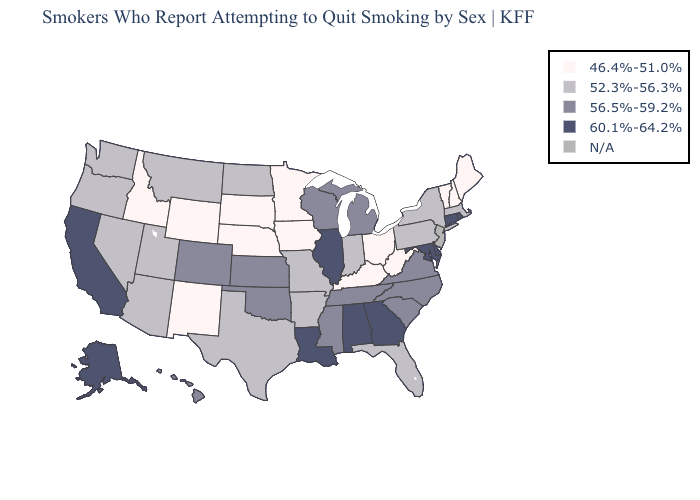Does Georgia have the lowest value in the USA?
Keep it brief. No. Does Washington have the highest value in the West?
Concise answer only. No. What is the lowest value in the South?
Quick response, please. 46.4%-51.0%. Name the states that have a value in the range 60.1%-64.2%?
Short answer required. Alabama, Alaska, California, Connecticut, Delaware, Georgia, Illinois, Louisiana, Maryland, Rhode Island. Among the states that border Arizona , which have the highest value?
Give a very brief answer. California. What is the value of Michigan?
Be succinct. 56.5%-59.2%. Name the states that have a value in the range 52.3%-56.3%?
Concise answer only. Arizona, Arkansas, Florida, Indiana, Massachusetts, Missouri, Montana, Nevada, New York, North Dakota, Oregon, Pennsylvania, Texas, Utah, Washington. Name the states that have a value in the range 46.4%-51.0%?
Be succinct. Idaho, Iowa, Kentucky, Maine, Minnesota, Nebraska, New Hampshire, New Mexico, Ohio, South Dakota, Vermont, West Virginia, Wyoming. Does Maryland have the lowest value in the South?
Be succinct. No. What is the value of Kentucky?
Answer briefly. 46.4%-51.0%. Name the states that have a value in the range 52.3%-56.3%?
Write a very short answer. Arizona, Arkansas, Florida, Indiana, Massachusetts, Missouri, Montana, Nevada, New York, North Dakota, Oregon, Pennsylvania, Texas, Utah, Washington. What is the lowest value in states that border South Carolina?
Be succinct. 56.5%-59.2%. Does Illinois have the highest value in the USA?
Be succinct. Yes. Name the states that have a value in the range 46.4%-51.0%?
Write a very short answer. Idaho, Iowa, Kentucky, Maine, Minnesota, Nebraska, New Hampshire, New Mexico, Ohio, South Dakota, Vermont, West Virginia, Wyoming. 